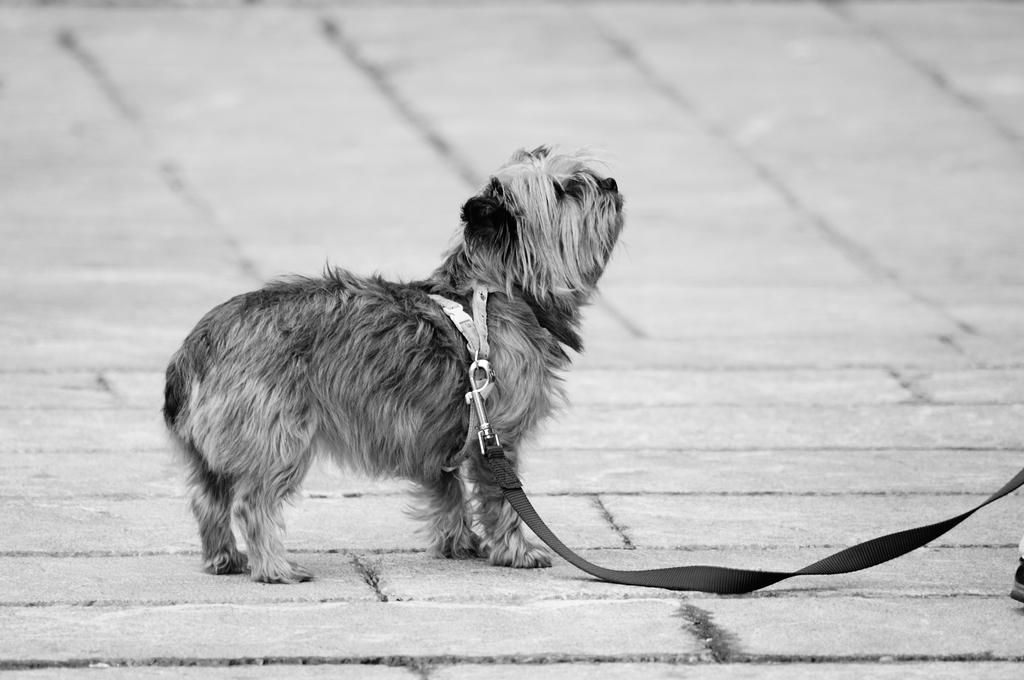What is the color scheme of the image? The image is black and white. What animal can be seen in the image? There is a dog in the image. Where is the dog located in the image? The dog is standing on the floor. What type of iron is the dog using in the image? There is no iron present in the image, and the dog is not using any tools or objects. 